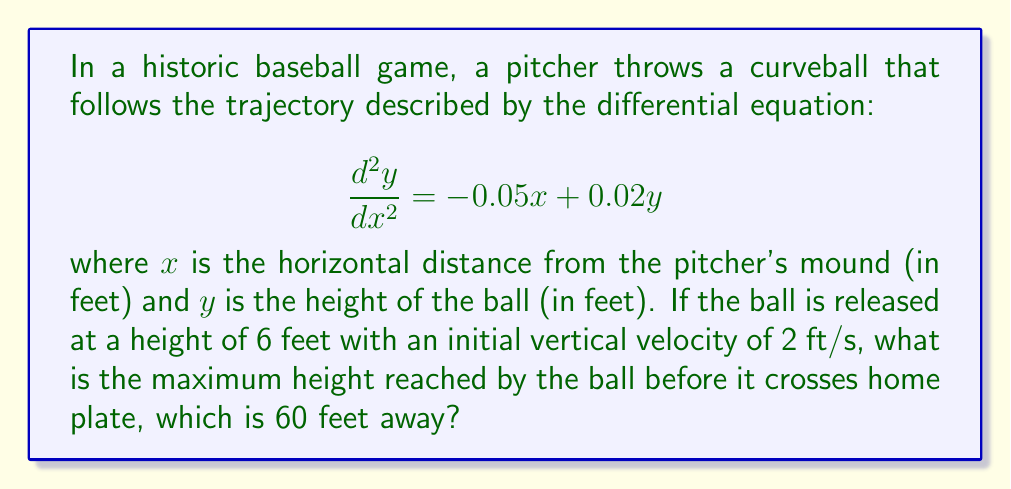Can you solve this math problem? To solve this problem, we'll follow these steps:

1) First, we need to solve the given differential equation. The general solution for this type of equation is:

   $$y(x) = c_1e^{rx} + c_2e^{sx} + Ax + B$$

   where $r$ and $s$ are roots of the characteristic equation $m^2 = 0.02$, and $A$ and $B$ are particular solutions.

2) Solving the characteristic equation:
   
   $$m = \pm\sqrt{0.02} = \pm0.1414$$

3) For the particular solution, we guess $y = ax + b$. Substituting this into the original equation:

   $$0 = -0.05x + 0.02(ax + b)$$
   
   $$0 = (-0.05 + 0.02a)x + 0.02b$$

   Equating coefficients:
   $$-0.05 + 0.02a = 0 \implies a = 2.5$$
   $$0.02b = 0 \implies b = 0$$

4) Therefore, the general solution is:

   $$y(x) = c_1e^{0.1414x} + c_2e^{-0.1414x} + 2.5x$$

5) Now we use the initial conditions. At $x=0$:
   
   $y(0) = 6$ and $y'(0) = 2$

6) Applying these conditions:

   $$6 = c_1 + c_2$$
   $$2 = 0.1414c_1 - 0.1414c_2 + 2.5$$

7) Solving these equations:

   $$c_1 = 4.5355, c_2 = 1.4645$$

8) The final equation of the trajectory is:

   $$y(x) = 4.5355e^{0.1414x} + 1.4645e^{-0.1414x} + 2.5x$$

9) To find the maximum height, we differentiate and set to zero:

   $$\frac{dy}{dx} = 0.6413e^{0.1414x} - 0.2071e^{-0.1414x} + 2.5 = 0$$

10) This equation can't be solved analytically. Using numerical methods, we find that the maximum occurs at approximately $x = 30.8$ feet.

11) Substituting this back into the trajectory equation:

    $$y(30.8) \approx 10.2 \text{ feet}$$

Therefore, the maximum height reached by the ball is approximately 10.2 feet.
Answer: 10.2 feet 